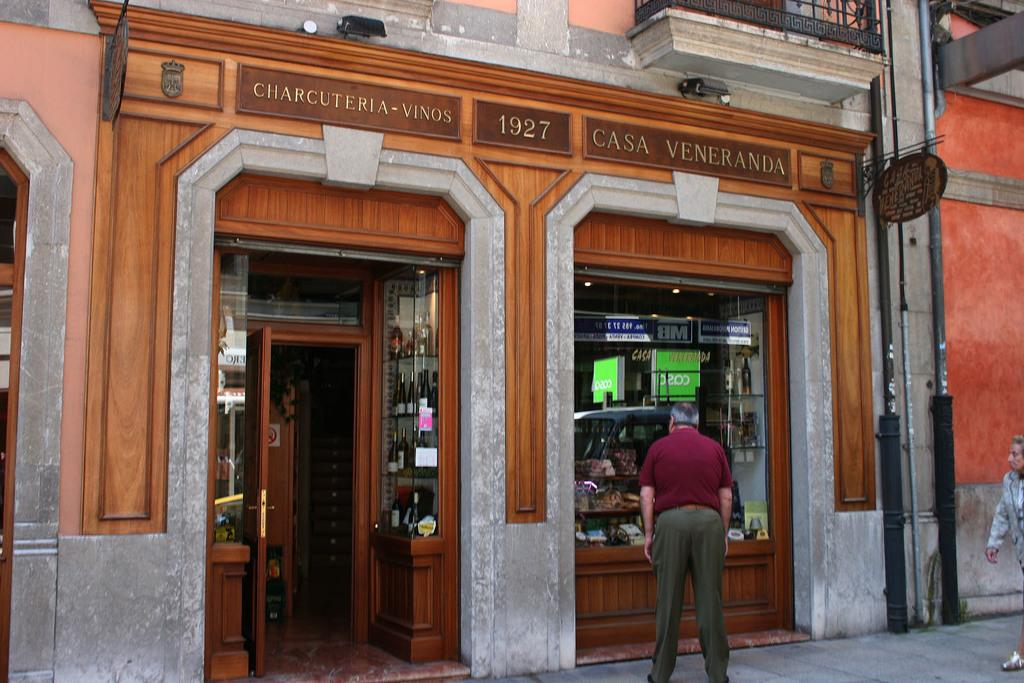<image>
Describe the image concisely. A Charcuteria-Vinos store has a wooden storefront from 1927. 